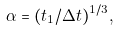Convert formula to latex. <formula><loc_0><loc_0><loc_500><loc_500>\alpha = ( t _ { 1 } / \Delta t ) ^ { 1 / 3 } ,</formula> 